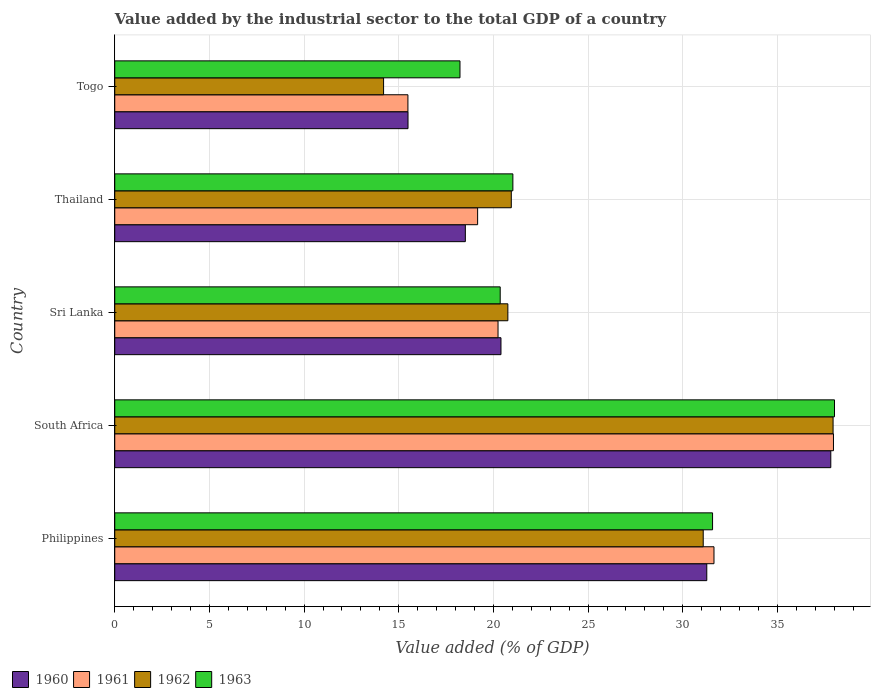How many different coloured bars are there?
Make the answer very short. 4. How many groups of bars are there?
Provide a succinct answer. 5. Are the number of bars per tick equal to the number of legend labels?
Ensure brevity in your answer.  Yes. How many bars are there on the 4th tick from the bottom?
Ensure brevity in your answer.  4. What is the label of the 1st group of bars from the top?
Ensure brevity in your answer.  Togo. In how many cases, is the number of bars for a given country not equal to the number of legend labels?
Ensure brevity in your answer.  0. What is the value added by the industrial sector to the total GDP in 1962 in Sri Lanka?
Your response must be concise. 20.76. Across all countries, what is the maximum value added by the industrial sector to the total GDP in 1963?
Offer a very short reply. 38.01. Across all countries, what is the minimum value added by the industrial sector to the total GDP in 1961?
Ensure brevity in your answer.  15.48. In which country was the value added by the industrial sector to the total GDP in 1960 maximum?
Your answer should be very brief. South Africa. In which country was the value added by the industrial sector to the total GDP in 1963 minimum?
Keep it short and to the point. Togo. What is the total value added by the industrial sector to the total GDP in 1963 in the graph?
Ensure brevity in your answer.  129.2. What is the difference between the value added by the industrial sector to the total GDP in 1963 in Philippines and that in Sri Lanka?
Your response must be concise. 11.22. What is the difference between the value added by the industrial sector to the total GDP in 1962 in Togo and the value added by the industrial sector to the total GDP in 1960 in Philippines?
Provide a short and direct response. -17.07. What is the average value added by the industrial sector to the total GDP in 1960 per country?
Make the answer very short. 24.7. What is the difference between the value added by the industrial sector to the total GDP in 1960 and value added by the industrial sector to the total GDP in 1963 in Thailand?
Your response must be concise. -2.51. What is the ratio of the value added by the industrial sector to the total GDP in 1962 in Sri Lanka to that in Thailand?
Your answer should be compact. 0.99. Is the difference between the value added by the industrial sector to the total GDP in 1960 in Sri Lanka and Togo greater than the difference between the value added by the industrial sector to the total GDP in 1963 in Sri Lanka and Togo?
Offer a very short reply. Yes. What is the difference between the highest and the second highest value added by the industrial sector to the total GDP in 1960?
Offer a terse response. 6.55. What is the difference between the highest and the lowest value added by the industrial sector to the total GDP in 1963?
Make the answer very short. 19.78. In how many countries, is the value added by the industrial sector to the total GDP in 1962 greater than the average value added by the industrial sector to the total GDP in 1962 taken over all countries?
Provide a short and direct response. 2. What does the 3rd bar from the top in Philippines represents?
Give a very brief answer. 1961. What does the 4th bar from the bottom in Thailand represents?
Offer a terse response. 1963. Is it the case that in every country, the sum of the value added by the industrial sector to the total GDP in 1963 and value added by the industrial sector to the total GDP in 1962 is greater than the value added by the industrial sector to the total GDP in 1960?
Keep it short and to the point. Yes. What is the difference between two consecutive major ticks on the X-axis?
Provide a short and direct response. 5. Are the values on the major ticks of X-axis written in scientific E-notation?
Your answer should be very brief. No. Does the graph contain any zero values?
Your response must be concise. No. Does the graph contain grids?
Provide a succinct answer. Yes. How many legend labels are there?
Offer a terse response. 4. How are the legend labels stacked?
Make the answer very short. Horizontal. What is the title of the graph?
Keep it short and to the point. Value added by the industrial sector to the total GDP of a country. What is the label or title of the X-axis?
Keep it short and to the point. Value added (% of GDP). What is the Value added (% of GDP) of 1960 in Philippines?
Your answer should be compact. 31.27. What is the Value added (% of GDP) of 1961 in Philippines?
Your answer should be compact. 31.65. What is the Value added (% of GDP) in 1962 in Philippines?
Make the answer very short. 31.08. What is the Value added (% of GDP) of 1963 in Philippines?
Offer a very short reply. 31.57. What is the Value added (% of GDP) of 1960 in South Africa?
Offer a very short reply. 37.82. What is the Value added (% of GDP) in 1961 in South Africa?
Provide a succinct answer. 37.96. What is the Value added (% of GDP) in 1962 in South Africa?
Keep it short and to the point. 37.94. What is the Value added (% of GDP) of 1963 in South Africa?
Ensure brevity in your answer.  38.01. What is the Value added (% of GDP) in 1960 in Sri Lanka?
Your response must be concise. 20.4. What is the Value added (% of GDP) in 1961 in Sri Lanka?
Provide a succinct answer. 20.24. What is the Value added (% of GDP) in 1962 in Sri Lanka?
Provide a succinct answer. 20.76. What is the Value added (% of GDP) of 1963 in Sri Lanka?
Make the answer very short. 20.36. What is the Value added (% of GDP) in 1960 in Thailand?
Make the answer very short. 18.52. What is the Value added (% of GDP) in 1961 in Thailand?
Offer a very short reply. 19.16. What is the Value added (% of GDP) of 1962 in Thailand?
Your answer should be compact. 20.94. What is the Value added (% of GDP) in 1963 in Thailand?
Your answer should be compact. 21.03. What is the Value added (% of GDP) of 1960 in Togo?
Offer a very short reply. 15.49. What is the Value added (% of GDP) of 1961 in Togo?
Provide a succinct answer. 15.48. What is the Value added (% of GDP) in 1962 in Togo?
Your response must be concise. 14.2. What is the Value added (% of GDP) in 1963 in Togo?
Offer a terse response. 18.23. Across all countries, what is the maximum Value added (% of GDP) in 1960?
Your answer should be very brief. 37.82. Across all countries, what is the maximum Value added (% of GDP) of 1961?
Offer a very short reply. 37.96. Across all countries, what is the maximum Value added (% of GDP) in 1962?
Your response must be concise. 37.94. Across all countries, what is the maximum Value added (% of GDP) of 1963?
Make the answer very short. 38.01. Across all countries, what is the minimum Value added (% of GDP) of 1960?
Offer a very short reply. 15.49. Across all countries, what is the minimum Value added (% of GDP) in 1961?
Your response must be concise. 15.48. Across all countries, what is the minimum Value added (% of GDP) of 1962?
Give a very brief answer. 14.2. Across all countries, what is the minimum Value added (% of GDP) of 1963?
Give a very brief answer. 18.23. What is the total Value added (% of GDP) in 1960 in the graph?
Provide a succinct answer. 123.49. What is the total Value added (% of GDP) of 1961 in the graph?
Keep it short and to the point. 124.5. What is the total Value added (% of GDP) in 1962 in the graph?
Provide a short and direct response. 124.92. What is the total Value added (% of GDP) of 1963 in the graph?
Ensure brevity in your answer.  129.2. What is the difference between the Value added (% of GDP) in 1960 in Philippines and that in South Africa?
Make the answer very short. -6.55. What is the difference between the Value added (% of GDP) of 1961 in Philippines and that in South Africa?
Provide a short and direct response. -6.31. What is the difference between the Value added (% of GDP) in 1962 in Philippines and that in South Africa?
Keep it short and to the point. -6.86. What is the difference between the Value added (% of GDP) in 1963 in Philippines and that in South Africa?
Ensure brevity in your answer.  -6.44. What is the difference between the Value added (% of GDP) of 1960 in Philippines and that in Sri Lanka?
Make the answer very short. 10.87. What is the difference between the Value added (% of GDP) in 1961 in Philippines and that in Sri Lanka?
Your answer should be very brief. 11.41. What is the difference between the Value added (% of GDP) of 1962 in Philippines and that in Sri Lanka?
Your answer should be compact. 10.32. What is the difference between the Value added (% of GDP) in 1963 in Philippines and that in Sri Lanka?
Your answer should be very brief. 11.22. What is the difference between the Value added (% of GDP) in 1960 in Philippines and that in Thailand?
Offer a terse response. 12.75. What is the difference between the Value added (% of GDP) in 1961 in Philippines and that in Thailand?
Give a very brief answer. 12.48. What is the difference between the Value added (% of GDP) in 1962 in Philippines and that in Thailand?
Make the answer very short. 10.14. What is the difference between the Value added (% of GDP) of 1963 in Philippines and that in Thailand?
Your answer should be compact. 10.55. What is the difference between the Value added (% of GDP) in 1960 in Philippines and that in Togo?
Keep it short and to the point. 15.78. What is the difference between the Value added (% of GDP) of 1961 in Philippines and that in Togo?
Give a very brief answer. 16.16. What is the difference between the Value added (% of GDP) of 1962 in Philippines and that in Togo?
Provide a succinct answer. 16.88. What is the difference between the Value added (% of GDP) of 1963 in Philippines and that in Togo?
Ensure brevity in your answer.  13.34. What is the difference between the Value added (% of GDP) of 1960 in South Africa and that in Sri Lanka?
Make the answer very short. 17.42. What is the difference between the Value added (% of GDP) of 1961 in South Africa and that in Sri Lanka?
Keep it short and to the point. 17.72. What is the difference between the Value added (% of GDP) in 1962 in South Africa and that in Sri Lanka?
Offer a very short reply. 17.18. What is the difference between the Value added (% of GDP) in 1963 in South Africa and that in Sri Lanka?
Keep it short and to the point. 17.66. What is the difference between the Value added (% of GDP) in 1960 in South Africa and that in Thailand?
Keep it short and to the point. 19.3. What is the difference between the Value added (% of GDP) in 1961 in South Africa and that in Thailand?
Give a very brief answer. 18.79. What is the difference between the Value added (% of GDP) in 1962 in South Africa and that in Thailand?
Keep it short and to the point. 17. What is the difference between the Value added (% of GDP) in 1963 in South Africa and that in Thailand?
Your response must be concise. 16.99. What is the difference between the Value added (% of GDP) in 1960 in South Africa and that in Togo?
Make the answer very short. 22.33. What is the difference between the Value added (% of GDP) in 1961 in South Africa and that in Togo?
Give a very brief answer. 22.48. What is the difference between the Value added (% of GDP) in 1962 in South Africa and that in Togo?
Your answer should be compact. 23.74. What is the difference between the Value added (% of GDP) of 1963 in South Africa and that in Togo?
Offer a terse response. 19.78. What is the difference between the Value added (% of GDP) in 1960 in Sri Lanka and that in Thailand?
Make the answer very short. 1.88. What is the difference between the Value added (% of GDP) of 1961 in Sri Lanka and that in Thailand?
Your answer should be compact. 1.08. What is the difference between the Value added (% of GDP) of 1962 in Sri Lanka and that in Thailand?
Your answer should be very brief. -0.18. What is the difference between the Value added (% of GDP) of 1963 in Sri Lanka and that in Thailand?
Offer a very short reply. -0.67. What is the difference between the Value added (% of GDP) in 1960 in Sri Lanka and that in Togo?
Your response must be concise. 4.91. What is the difference between the Value added (% of GDP) of 1961 in Sri Lanka and that in Togo?
Offer a very short reply. 4.76. What is the difference between the Value added (% of GDP) in 1962 in Sri Lanka and that in Togo?
Offer a very short reply. 6.56. What is the difference between the Value added (% of GDP) in 1963 in Sri Lanka and that in Togo?
Offer a terse response. 2.12. What is the difference between the Value added (% of GDP) in 1960 in Thailand and that in Togo?
Keep it short and to the point. 3.03. What is the difference between the Value added (% of GDP) in 1961 in Thailand and that in Togo?
Offer a very short reply. 3.68. What is the difference between the Value added (% of GDP) in 1962 in Thailand and that in Togo?
Provide a short and direct response. 6.75. What is the difference between the Value added (% of GDP) of 1963 in Thailand and that in Togo?
Your answer should be very brief. 2.79. What is the difference between the Value added (% of GDP) of 1960 in Philippines and the Value added (% of GDP) of 1961 in South Africa?
Offer a very short reply. -6.69. What is the difference between the Value added (% of GDP) in 1960 in Philippines and the Value added (% of GDP) in 1962 in South Africa?
Your answer should be very brief. -6.67. What is the difference between the Value added (% of GDP) in 1960 in Philippines and the Value added (% of GDP) in 1963 in South Africa?
Give a very brief answer. -6.75. What is the difference between the Value added (% of GDP) in 1961 in Philippines and the Value added (% of GDP) in 1962 in South Africa?
Your answer should be compact. -6.29. What is the difference between the Value added (% of GDP) of 1961 in Philippines and the Value added (% of GDP) of 1963 in South Africa?
Give a very brief answer. -6.37. What is the difference between the Value added (% of GDP) in 1962 in Philippines and the Value added (% of GDP) in 1963 in South Africa?
Your answer should be compact. -6.93. What is the difference between the Value added (% of GDP) in 1960 in Philippines and the Value added (% of GDP) in 1961 in Sri Lanka?
Your answer should be very brief. 11.03. What is the difference between the Value added (% of GDP) of 1960 in Philippines and the Value added (% of GDP) of 1962 in Sri Lanka?
Your answer should be very brief. 10.51. What is the difference between the Value added (% of GDP) of 1960 in Philippines and the Value added (% of GDP) of 1963 in Sri Lanka?
Ensure brevity in your answer.  10.91. What is the difference between the Value added (% of GDP) in 1961 in Philippines and the Value added (% of GDP) in 1962 in Sri Lanka?
Provide a succinct answer. 10.89. What is the difference between the Value added (% of GDP) of 1961 in Philippines and the Value added (% of GDP) of 1963 in Sri Lanka?
Provide a succinct answer. 11.29. What is the difference between the Value added (% of GDP) of 1962 in Philippines and the Value added (% of GDP) of 1963 in Sri Lanka?
Ensure brevity in your answer.  10.72. What is the difference between the Value added (% of GDP) of 1960 in Philippines and the Value added (% of GDP) of 1961 in Thailand?
Your answer should be compact. 12.1. What is the difference between the Value added (% of GDP) of 1960 in Philippines and the Value added (% of GDP) of 1962 in Thailand?
Keep it short and to the point. 10.33. What is the difference between the Value added (% of GDP) of 1960 in Philippines and the Value added (% of GDP) of 1963 in Thailand?
Make the answer very short. 10.24. What is the difference between the Value added (% of GDP) of 1961 in Philippines and the Value added (% of GDP) of 1962 in Thailand?
Provide a succinct answer. 10.71. What is the difference between the Value added (% of GDP) in 1961 in Philippines and the Value added (% of GDP) in 1963 in Thailand?
Keep it short and to the point. 10.62. What is the difference between the Value added (% of GDP) in 1962 in Philippines and the Value added (% of GDP) in 1963 in Thailand?
Ensure brevity in your answer.  10.05. What is the difference between the Value added (% of GDP) of 1960 in Philippines and the Value added (% of GDP) of 1961 in Togo?
Ensure brevity in your answer.  15.78. What is the difference between the Value added (% of GDP) in 1960 in Philippines and the Value added (% of GDP) in 1962 in Togo?
Provide a short and direct response. 17.07. What is the difference between the Value added (% of GDP) of 1960 in Philippines and the Value added (% of GDP) of 1963 in Togo?
Keep it short and to the point. 13.03. What is the difference between the Value added (% of GDP) of 1961 in Philippines and the Value added (% of GDP) of 1962 in Togo?
Provide a short and direct response. 17.45. What is the difference between the Value added (% of GDP) in 1961 in Philippines and the Value added (% of GDP) in 1963 in Togo?
Offer a very short reply. 13.41. What is the difference between the Value added (% of GDP) of 1962 in Philippines and the Value added (% of GDP) of 1963 in Togo?
Offer a very short reply. 12.85. What is the difference between the Value added (% of GDP) of 1960 in South Africa and the Value added (% of GDP) of 1961 in Sri Lanka?
Ensure brevity in your answer.  17.57. What is the difference between the Value added (% of GDP) in 1960 in South Africa and the Value added (% of GDP) in 1962 in Sri Lanka?
Keep it short and to the point. 17.06. What is the difference between the Value added (% of GDP) of 1960 in South Africa and the Value added (% of GDP) of 1963 in Sri Lanka?
Provide a succinct answer. 17.46. What is the difference between the Value added (% of GDP) of 1961 in South Africa and the Value added (% of GDP) of 1962 in Sri Lanka?
Your answer should be compact. 17.2. What is the difference between the Value added (% of GDP) of 1961 in South Africa and the Value added (% of GDP) of 1963 in Sri Lanka?
Provide a succinct answer. 17.6. What is the difference between the Value added (% of GDP) in 1962 in South Africa and the Value added (% of GDP) in 1963 in Sri Lanka?
Give a very brief answer. 17.58. What is the difference between the Value added (% of GDP) of 1960 in South Africa and the Value added (% of GDP) of 1961 in Thailand?
Offer a terse response. 18.65. What is the difference between the Value added (% of GDP) in 1960 in South Africa and the Value added (% of GDP) in 1962 in Thailand?
Your answer should be very brief. 16.87. What is the difference between the Value added (% of GDP) of 1960 in South Africa and the Value added (% of GDP) of 1963 in Thailand?
Your answer should be very brief. 16.79. What is the difference between the Value added (% of GDP) in 1961 in South Africa and the Value added (% of GDP) in 1962 in Thailand?
Provide a succinct answer. 17.02. What is the difference between the Value added (% of GDP) in 1961 in South Africa and the Value added (% of GDP) in 1963 in Thailand?
Ensure brevity in your answer.  16.93. What is the difference between the Value added (% of GDP) of 1962 in South Africa and the Value added (% of GDP) of 1963 in Thailand?
Your answer should be compact. 16.91. What is the difference between the Value added (% of GDP) in 1960 in South Africa and the Value added (% of GDP) in 1961 in Togo?
Your answer should be very brief. 22.33. What is the difference between the Value added (% of GDP) in 1960 in South Africa and the Value added (% of GDP) in 1962 in Togo?
Give a very brief answer. 23.62. What is the difference between the Value added (% of GDP) in 1960 in South Africa and the Value added (% of GDP) in 1963 in Togo?
Offer a very short reply. 19.58. What is the difference between the Value added (% of GDP) in 1961 in South Africa and the Value added (% of GDP) in 1962 in Togo?
Provide a succinct answer. 23.76. What is the difference between the Value added (% of GDP) in 1961 in South Africa and the Value added (% of GDP) in 1963 in Togo?
Offer a very short reply. 19.73. What is the difference between the Value added (% of GDP) of 1962 in South Africa and the Value added (% of GDP) of 1963 in Togo?
Your answer should be very brief. 19.7. What is the difference between the Value added (% of GDP) of 1960 in Sri Lanka and the Value added (% of GDP) of 1961 in Thailand?
Provide a succinct answer. 1.23. What is the difference between the Value added (% of GDP) in 1960 in Sri Lanka and the Value added (% of GDP) in 1962 in Thailand?
Keep it short and to the point. -0.54. What is the difference between the Value added (% of GDP) in 1960 in Sri Lanka and the Value added (% of GDP) in 1963 in Thailand?
Give a very brief answer. -0.63. What is the difference between the Value added (% of GDP) in 1961 in Sri Lanka and the Value added (% of GDP) in 1962 in Thailand?
Your answer should be very brief. -0.7. What is the difference between the Value added (% of GDP) of 1961 in Sri Lanka and the Value added (% of GDP) of 1963 in Thailand?
Make the answer very short. -0.78. What is the difference between the Value added (% of GDP) of 1962 in Sri Lanka and the Value added (% of GDP) of 1963 in Thailand?
Give a very brief answer. -0.27. What is the difference between the Value added (% of GDP) in 1960 in Sri Lanka and the Value added (% of GDP) in 1961 in Togo?
Provide a short and direct response. 4.91. What is the difference between the Value added (% of GDP) of 1960 in Sri Lanka and the Value added (% of GDP) of 1962 in Togo?
Your answer should be very brief. 6.2. What is the difference between the Value added (% of GDP) of 1960 in Sri Lanka and the Value added (% of GDP) of 1963 in Togo?
Your answer should be compact. 2.16. What is the difference between the Value added (% of GDP) of 1961 in Sri Lanka and the Value added (% of GDP) of 1962 in Togo?
Your answer should be compact. 6.05. What is the difference between the Value added (% of GDP) of 1961 in Sri Lanka and the Value added (% of GDP) of 1963 in Togo?
Offer a terse response. 2.01. What is the difference between the Value added (% of GDP) in 1962 in Sri Lanka and the Value added (% of GDP) in 1963 in Togo?
Your answer should be compact. 2.53. What is the difference between the Value added (% of GDP) in 1960 in Thailand and the Value added (% of GDP) in 1961 in Togo?
Ensure brevity in your answer.  3.03. What is the difference between the Value added (% of GDP) in 1960 in Thailand and the Value added (% of GDP) in 1962 in Togo?
Offer a terse response. 4.32. What is the difference between the Value added (% of GDP) in 1960 in Thailand and the Value added (% of GDP) in 1963 in Togo?
Keep it short and to the point. 0.28. What is the difference between the Value added (% of GDP) in 1961 in Thailand and the Value added (% of GDP) in 1962 in Togo?
Make the answer very short. 4.97. What is the difference between the Value added (% of GDP) of 1961 in Thailand and the Value added (% of GDP) of 1963 in Togo?
Your answer should be compact. 0.93. What is the difference between the Value added (% of GDP) in 1962 in Thailand and the Value added (% of GDP) in 1963 in Togo?
Provide a succinct answer. 2.71. What is the average Value added (% of GDP) of 1960 per country?
Ensure brevity in your answer.  24.7. What is the average Value added (% of GDP) in 1961 per country?
Give a very brief answer. 24.9. What is the average Value added (% of GDP) of 1962 per country?
Offer a very short reply. 24.98. What is the average Value added (% of GDP) in 1963 per country?
Give a very brief answer. 25.84. What is the difference between the Value added (% of GDP) of 1960 and Value added (% of GDP) of 1961 in Philippines?
Your answer should be very brief. -0.38. What is the difference between the Value added (% of GDP) in 1960 and Value added (% of GDP) in 1962 in Philippines?
Give a very brief answer. 0.19. What is the difference between the Value added (% of GDP) in 1960 and Value added (% of GDP) in 1963 in Philippines?
Your answer should be compact. -0.3. What is the difference between the Value added (% of GDP) of 1961 and Value added (% of GDP) of 1962 in Philippines?
Offer a very short reply. 0.57. What is the difference between the Value added (% of GDP) in 1961 and Value added (% of GDP) in 1963 in Philippines?
Your answer should be very brief. 0.08. What is the difference between the Value added (% of GDP) of 1962 and Value added (% of GDP) of 1963 in Philippines?
Offer a terse response. -0.49. What is the difference between the Value added (% of GDP) of 1960 and Value added (% of GDP) of 1961 in South Africa?
Your answer should be very brief. -0.14. What is the difference between the Value added (% of GDP) in 1960 and Value added (% of GDP) in 1962 in South Africa?
Offer a very short reply. -0.12. What is the difference between the Value added (% of GDP) in 1960 and Value added (% of GDP) in 1963 in South Africa?
Provide a short and direct response. -0.2. What is the difference between the Value added (% of GDP) in 1961 and Value added (% of GDP) in 1962 in South Africa?
Make the answer very short. 0.02. What is the difference between the Value added (% of GDP) in 1961 and Value added (% of GDP) in 1963 in South Africa?
Keep it short and to the point. -0.05. What is the difference between the Value added (% of GDP) in 1962 and Value added (% of GDP) in 1963 in South Africa?
Keep it short and to the point. -0.08. What is the difference between the Value added (% of GDP) of 1960 and Value added (% of GDP) of 1961 in Sri Lanka?
Provide a succinct answer. 0.16. What is the difference between the Value added (% of GDP) in 1960 and Value added (% of GDP) in 1962 in Sri Lanka?
Offer a very short reply. -0.36. What is the difference between the Value added (% of GDP) of 1960 and Value added (% of GDP) of 1963 in Sri Lanka?
Your answer should be compact. 0.04. What is the difference between the Value added (% of GDP) of 1961 and Value added (% of GDP) of 1962 in Sri Lanka?
Offer a very short reply. -0.52. What is the difference between the Value added (% of GDP) of 1961 and Value added (% of GDP) of 1963 in Sri Lanka?
Your answer should be compact. -0.11. What is the difference between the Value added (% of GDP) in 1962 and Value added (% of GDP) in 1963 in Sri Lanka?
Your response must be concise. 0.4. What is the difference between the Value added (% of GDP) of 1960 and Value added (% of GDP) of 1961 in Thailand?
Give a very brief answer. -0.65. What is the difference between the Value added (% of GDP) of 1960 and Value added (% of GDP) of 1962 in Thailand?
Offer a terse response. -2.43. What is the difference between the Value added (% of GDP) of 1960 and Value added (% of GDP) of 1963 in Thailand?
Provide a short and direct response. -2.51. What is the difference between the Value added (% of GDP) of 1961 and Value added (% of GDP) of 1962 in Thailand?
Your answer should be compact. -1.78. What is the difference between the Value added (% of GDP) in 1961 and Value added (% of GDP) in 1963 in Thailand?
Ensure brevity in your answer.  -1.86. What is the difference between the Value added (% of GDP) in 1962 and Value added (% of GDP) in 1963 in Thailand?
Provide a short and direct response. -0.08. What is the difference between the Value added (% of GDP) of 1960 and Value added (% of GDP) of 1961 in Togo?
Your answer should be compact. 0. What is the difference between the Value added (% of GDP) in 1960 and Value added (% of GDP) in 1962 in Togo?
Provide a short and direct response. 1.29. What is the difference between the Value added (% of GDP) of 1960 and Value added (% of GDP) of 1963 in Togo?
Ensure brevity in your answer.  -2.75. What is the difference between the Value added (% of GDP) of 1961 and Value added (% of GDP) of 1962 in Togo?
Ensure brevity in your answer.  1.29. What is the difference between the Value added (% of GDP) in 1961 and Value added (% of GDP) in 1963 in Togo?
Provide a succinct answer. -2.75. What is the difference between the Value added (% of GDP) of 1962 and Value added (% of GDP) of 1963 in Togo?
Your answer should be very brief. -4.04. What is the ratio of the Value added (% of GDP) of 1960 in Philippines to that in South Africa?
Your response must be concise. 0.83. What is the ratio of the Value added (% of GDP) in 1961 in Philippines to that in South Africa?
Provide a succinct answer. 0.83. What is the ratio of the Value added (% of GDP) in 1962 in Philippines to that in South Africa?
Keep it short and to the point. 0.82. What is the ratio of the Value added (% of GDP) in 1963 in Philippines to that in South Africa?
Your response must be concise. 0.83. What is the ratio of the Value added (% of GDP) in 1960 in Philippines to that in Sri Lanka?
Your response must be concise. 1.53. What is the ratio of the Value added (% of GDP) in 1961 in Philippines to that in Sri Lanka?
Your answer should be compact. 1.56. What is the ratio of the Value added (% of GDP) in 1962 in Philippines to that in Sri Lanka?
Provide a short and direct response. 1.5. What is the ratio of the Value added (% of GDP) of 1963 in Philippines to that in Sri Lanka?
Offer a very short reply. 1.55. What is the ratio of the Value added (% of GDP) of 1960 in Philippines to that in Thailand?
Offer a terse response. 1.69. What is the ratio of the Value added (% of GDP) in 1961 in Philippines to that in Thailand?
Provide a succinct answer. 1.65. What is the ratio of the Value added (% of GDP) in 1962 in Philippines to that in Thailand?
Provide a succinct answer. 1.48. What is the ratio of the Value added (% of GDP) of 1963 in Philippines to that in Thailand?
Make the answer very short. 1.5. What is the ratio of the Value added (% of GDP) in 1960 in Philippines to that in Togo?
Keep it short and to the point. 2.02. What is the ratio of the Value added (% of GDP) in 1961 in Philippines to that in Togo?
Offer a terse response. 2.04. What is the ratio of the Value added (% of GDP) in 1962 in Philippines to that in Togo?
Ensure brevity in your answer.  2.19. What is the ratio of the Value added (% of GDP) of 1963 in Philippines to that in Togo?
Provide a succinct answer. 1.73. What is the ratio of the Value added (% of GDP) of 1960 in South Africa to that in Sri Lanka?
Your answer should be very brief. 1.85. What is the ratio of the Value added (% of GDP) of 1961 in South Africa to that in Sri Lanka?
Offer a very short reply. 1.88. What is the ratio of the Value added (% of GDP) in 1962 in South Africa to that in Sri Lanka?
Ensure brevity in your answer.  1.83. What is the ratio of the Value added (% of GDP) in 1963 in South Africa to that in Sri Lanka?
Your answer should be compact. 1.87. What is the ratio of the Value added (% of GDP) in 1960 in South Africa to that in Thailand?
Your answer should be very brief. 2.04. What is the ratio of the Value added (% of GDP) in 1961 in South Africa to that in Thailand?
Provide a succinct answer. 1.98. What is the ratio of the Value added (% of GDP) of 1962 in South Africa to that in Thailand?
Offer a terse response. 1.81. What is the ratio of the Value added (% of GDP) of 1963 in South Africa to that in Thailand?
Your answer should be very brief. 1.81. What is the ratio of the Value added (% of GDP) of 1960 in South Africa to that in Togo?
Keep it short and to the point. 2.44. What is the ratio of the Value added (% of GDP) in 1961 in South Africa to that in Togo?
Your answer should be very brief. 2.45. What is the ratio of the Value added (% of GDP) in 1962 in South Africa to that in Togo?
Make the answer very short. 2.67. What is the ratio of the Value added (% of GDP) in 1963 in South Africa to that in Togo?
Provide a short and direct response. 2.08. What is the ratio of the Value added (% of GDP) of 1960 in Sri Lanka to that in Thailand?
Provide a short and direct response. 1.1. What is the ratio of the Value added (% of GDP) of 1961 in Sri Lanka to that in Thailand?
Your response must be concise. 1.06. What is the ratio of the Value added (% of GDP) in 1963 in Sri Lanka to that in Thailand?
Ensure brevity in your answer.  0.97. What is the ratio of the Value added (% of GDP) of 1960 in Sri Lanka to that in Togo?
Your response must be concise. 1.32. What is the ratio of the Value added (% of GDP) of 1961 in Sri Lanka to that in Togo?
Your answer should be very brief. 1.31. What is the ratio of the Value added (% of GDP) of 1962 in Sri Lanka to that in Togo?
Provide a succinct answer. 1.46. What is the ratio of the Value added (% of GDP) of 1963 in Sri Lanka to that in Togo?
Keep it short and to the point. 1.12. What is the ratio of the Value added (% of GDP) in 1960 in Thailand to that in Togo?
Make the answer very short. 1.2. What is the ratio of the Value added (% of GDP) in 1961 in Thailand to that in Togo?
Your response must be concise. 1.24. What is the ratio of the Value added (% of GDP) in 1962 in Thailand to that in Togo?
Provide a succinct answer. 1.48. What is the ratio of the Value added (% of GDP) of 1963 in Thailand to that in Togo?
Ensure brevity in your answer.  1.15. What is the difference between the highest and the second highest Value added (% of GDP) in 1960?
Your answer should be compact. 6.55. What is the difference between the highest and the second highest Value added (% of GDP) of 1961?
Keep it short and to the point. 6.31. What is the difference between the highest and the second highest Value added (% of GDP) of 1962?
Keep it short and to the point. 6.86. What is the difference between the highest and the second highest Value added (% of GDP) in 1963?
Provide a short and direct response. 6.44. What is the difference between the highest and the lowest Value added (% of GDP) in 1960?
Ensure brevity in your answer.  22.33. What is the difference between the highest and the lowest Value added (% of GDP) in 1961?
Your response must be concise. 22.48. What is the difference between the highest and the lowest Value added (% of GDP) of 1962?
Offer a terse response. 23.74. What is the difference between the highest and the lowest Value added (% of GDP) of 1963?
Provide a short and direct response. 19.78. 